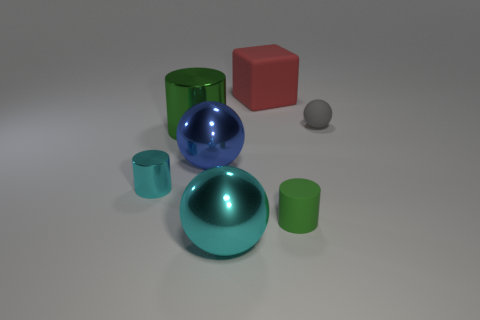Add 3 big metallic spheres. How many objects exist? 10 Subtract all rubber cylinders. How many cylinders are left? 2 Subtract all blue spheres. How many green cylinders are left? 2 Subtract 1 blocks. How many blocks are left? 0 Subtract all blue spheres. How many spheres are left? 2 Subtract 1 gray spheres. How many objects are left? 6 Subtract all spheres. How many objects are left? 4 Subtract all brown cylinders. Subtract all green balls. How many cylinders are left? 3 Subtract all matte cylinders. Subtract all small matte things. How many objects are left? 4 Add 2 green rubber cylinders. How many green rubber cylinders are left? 3 